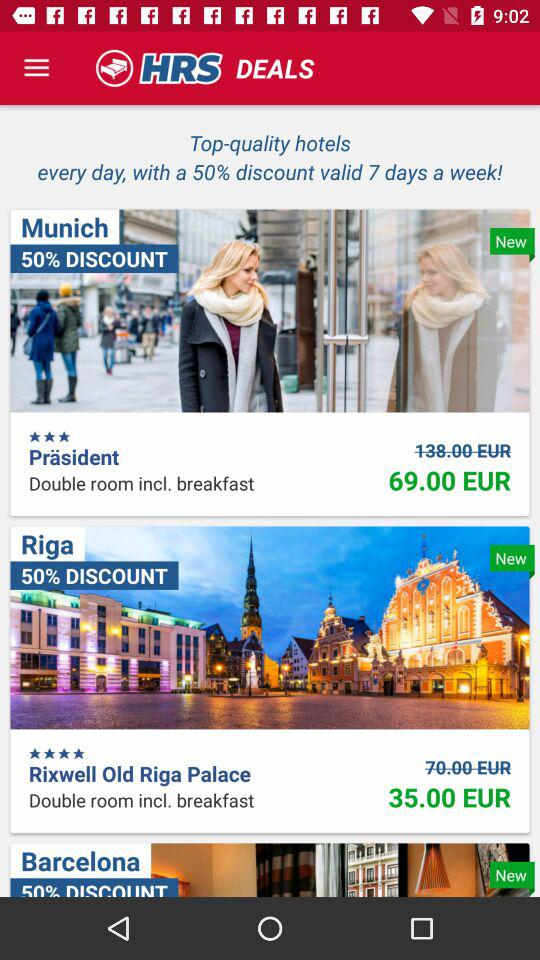For how many days is the discount valid? The discount is valid for 7 days a week. 